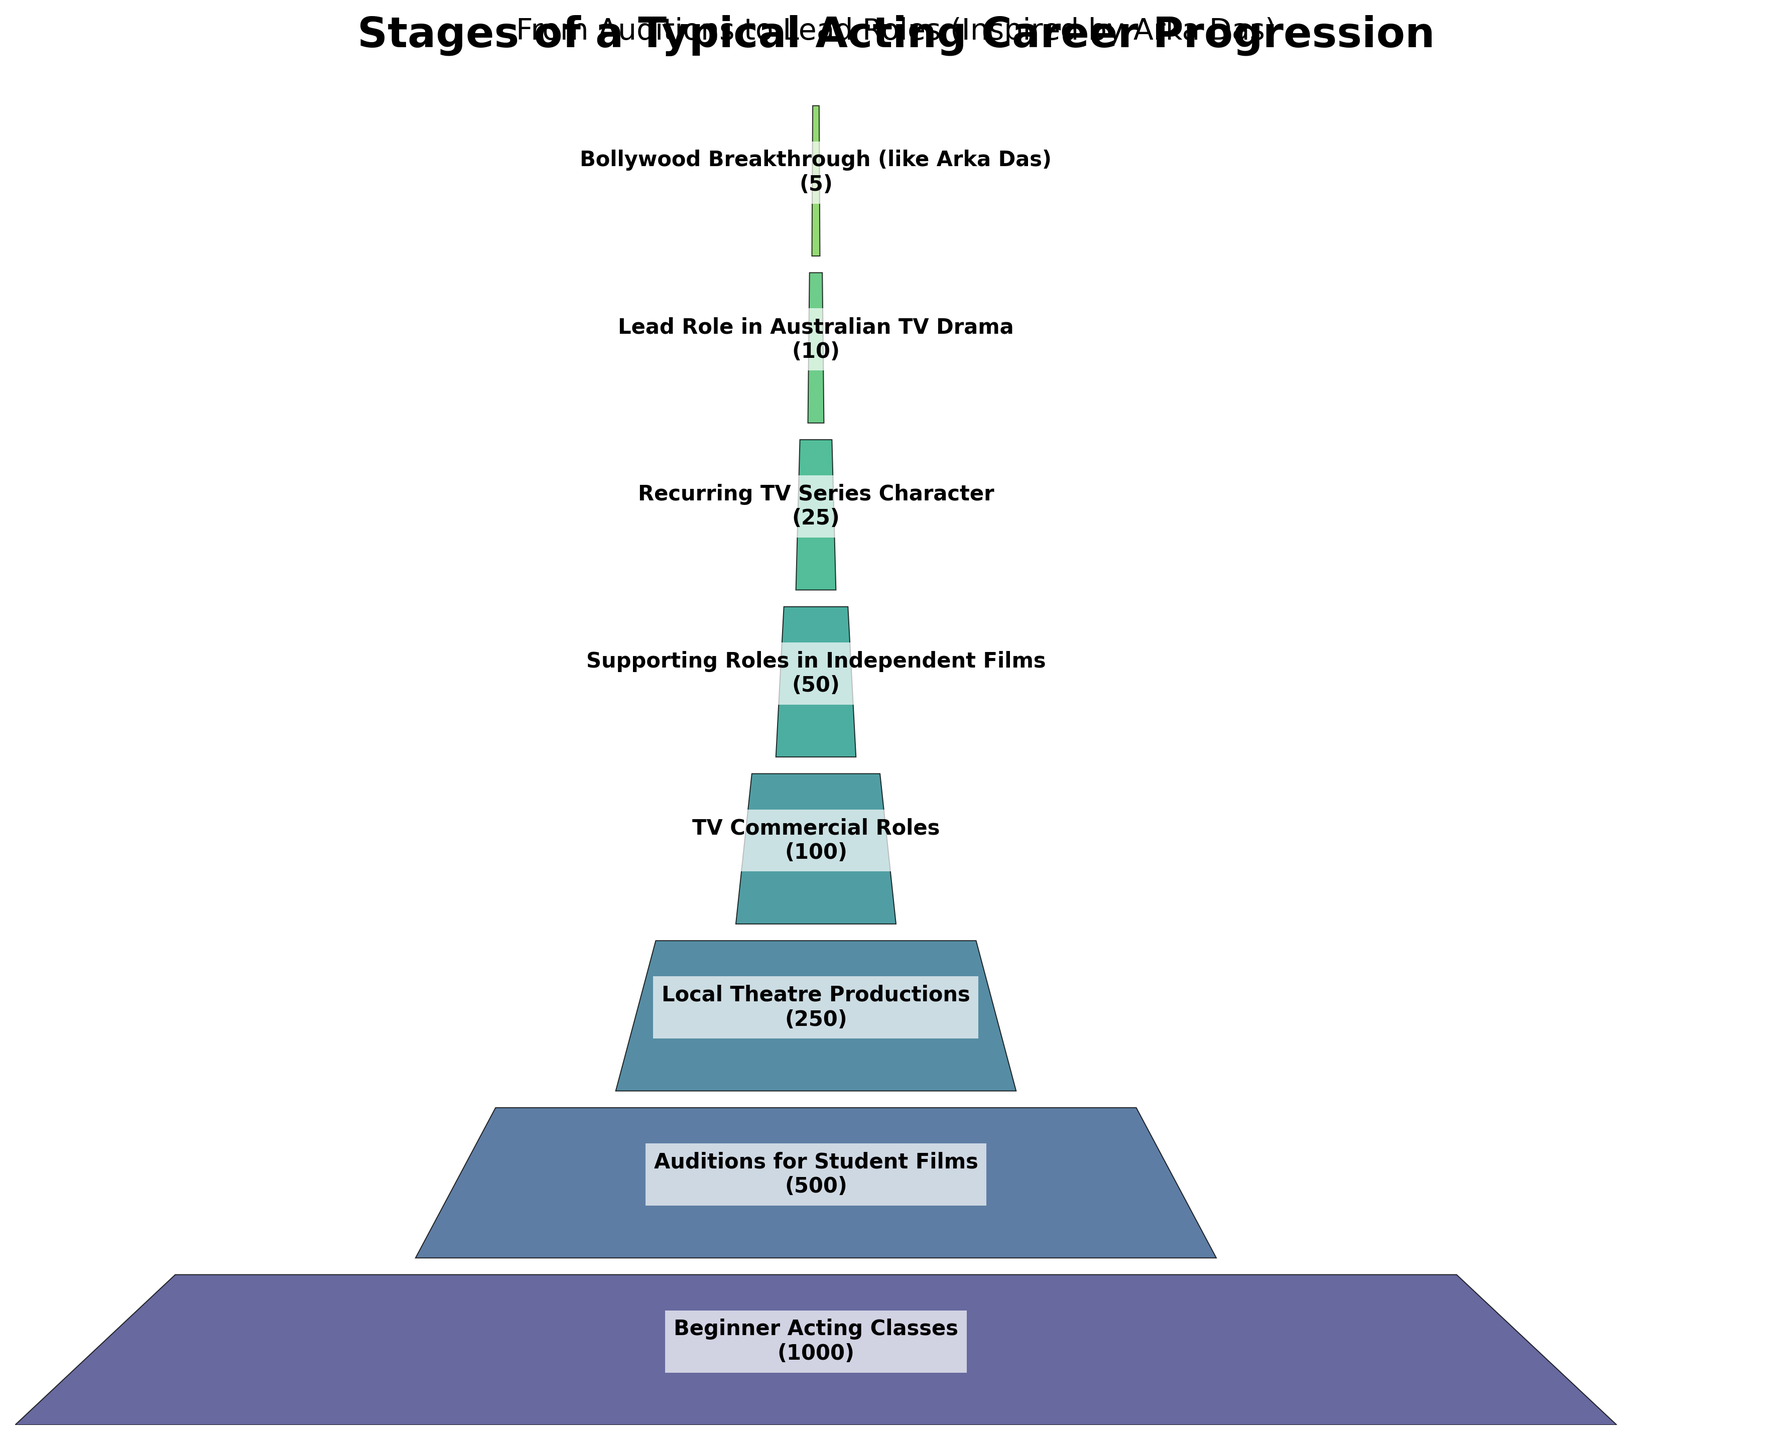What is the title of the figure? The title is located at the top of the figure. It clearly describes the purpose of the visualization.
Answer: Stages of a Typical Acting Career Progression How many stages are represented in the funnel chart? Count the number of distinct stages listed vertically in the chart.
Answer: 8 Which stage has the highest number of actors? Observe the width of each polygon and identify the widest one, which depicts the stage with the highest count of actors.
Answer: Beginner Acting Classes How many actors reach the Bollywood Breakthrough stage? Identify the Bollywood Breakthrough stage and refer to the actor count next to it.
Answer: 5 What is the difference in the number of actors between 'Beginner Acting Classes' and 'TV Commercial Roles'? Subtract the number of actors in 'TV Commercial Roles' from those in 'Beginner Acting Classes'. 1000 - 100 = 900.
Answer: 900 What happens to the number of actors as they progress to higher stages? Observe the trend in the width of polygons from top to bottom and note whether they increase or decrease.
Answer: Decrease By what factor does the number of actors decrease from 'Local Theatre Productions' to 'Lead Role in Australian TV Drama'? Divide the number of actors in 'Local Theatre Productions' by those in 'Lead Role in Australian TV Drama'. 250 / 10 = 25.
Answer: 25 What's the average number of actors in the middle three stages: 'Local Theatre Productions', 'TV Commercial Roles', and 'Supporting Roles in Independent Films'? Add actors in Local Theatre Productions (250), TV Commercial Roles (100), and Supporting Roles in Independent Films (50), then divide by 3. (250 + 100 + 50) / 3 = 133.33.
Answer: 133.33 Compare the number of actors in 'Recurring TV Series Character' and 'Lead Role in Australian TV Drama'. Which one has more actors and by how much? Both have respective counts of actors being 25 and 10. Then we subtract 10 from 25. 25 - 10 = 15.
Answer: Recurring TV Series Character, by 15 